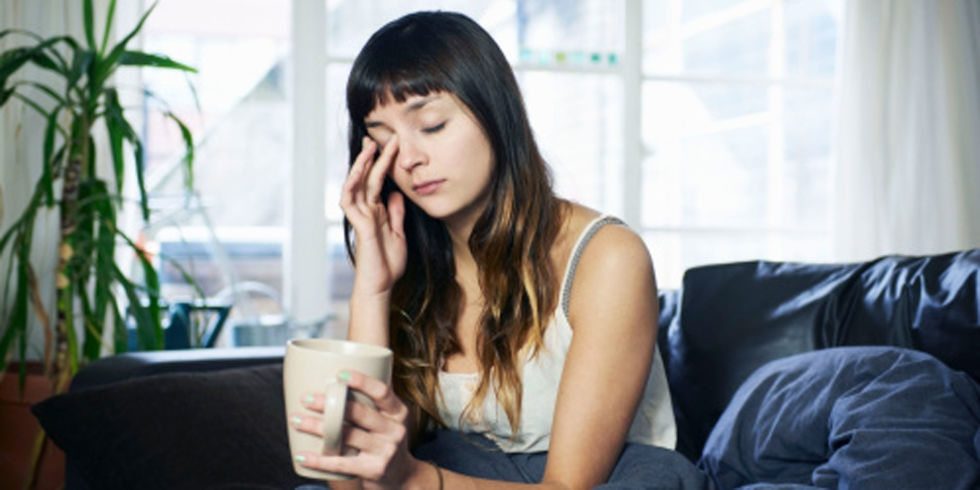Can you describe the style of the room in which the woman is sitting? The room has a contemporary, yet cozy aesthetic. The furniture includes a modern black sofa with comfortable cushions. The presence of a vibrant green plant adds a touch of nature and vitality. The overall ambiance feels lived-in and personal. What activity might the woman have been doing prior to this moment, based on the setting? Given her casual attire and the home setting, she could have been engaging in everyday activities such as enjoying a hot beverage, reading, or perhaps taking a break from working at home. The mug suggests she might have been drinking tea or coffee. 